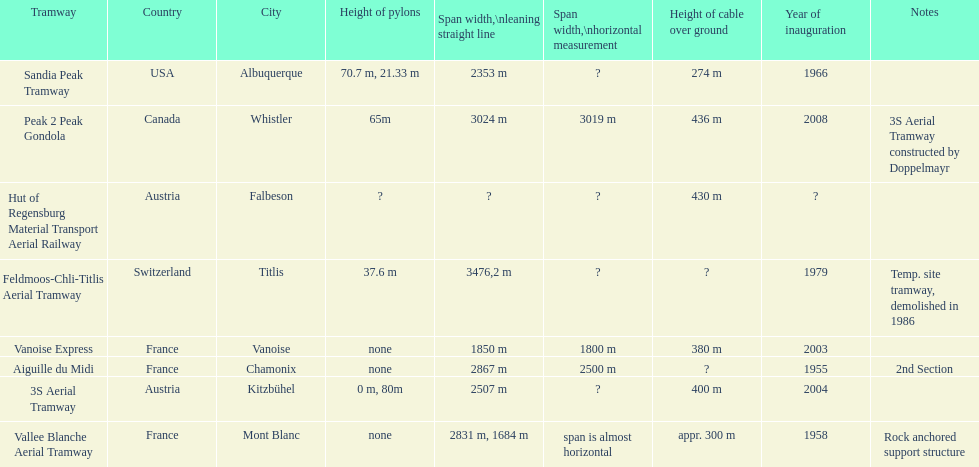At least how many aerial tramways were inaugurated after 1970? 4. 